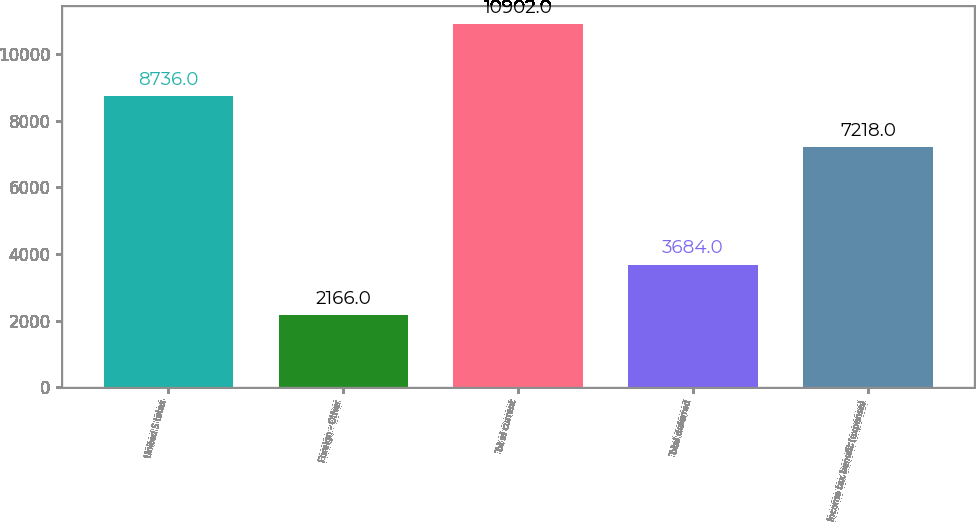Convert chart. <chart><loc_0><loc_0><loc_500><loc_500><bar_chart><fcel>United S tates<fcel>Foreign - Other<fcel>Tot al current<fcel>Total deferred<fcel>Income tax benefit (expense)<nl><fcel>8736<fcel>2166<fcel>10902<fcel>3684<fcel>7218<nl></chart> 